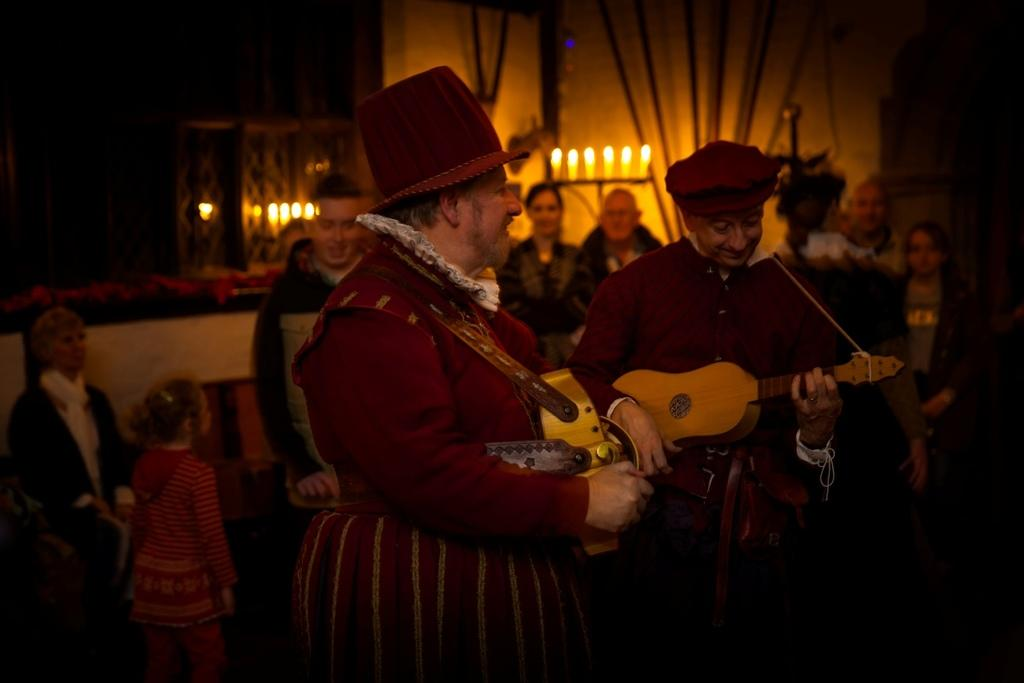How many people are in the image? There are two people in the image. What are the people doing in the image? The people are playing musical instruments. Can you describe any other objects or elements in the image? There are candles visible in the image, presumably at the back. What time is it according to the tin clock in the image? There is no tin clock present in the image. How many trains can be seen passing by in the image? There are no trains visible in the image. 